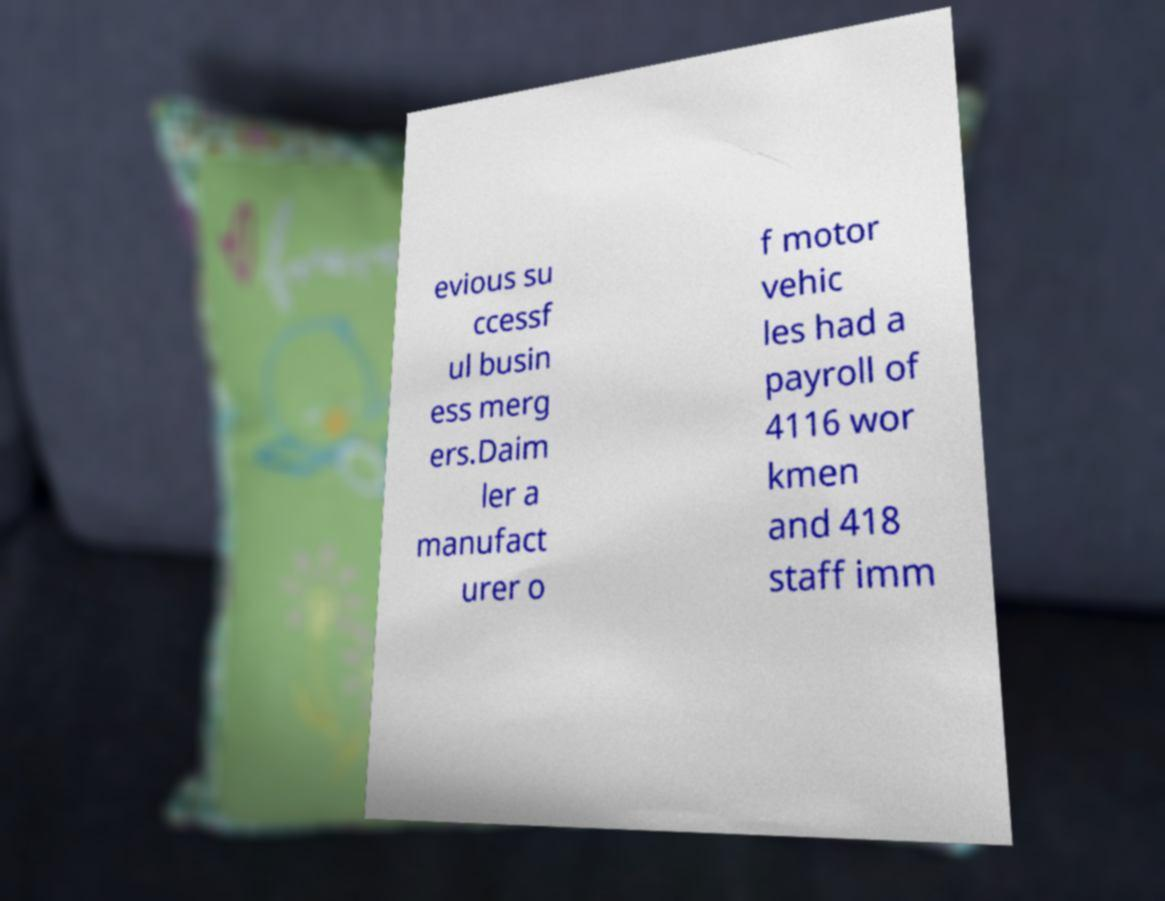For documentation purposes, I need the text within this image transcribed. Could you provide that? evious su ccessf ul busin ess merg ers.Daim ler a manufact urer o f motor vehic les had a payroll of 4116 wor kmen and 418 staff imm 